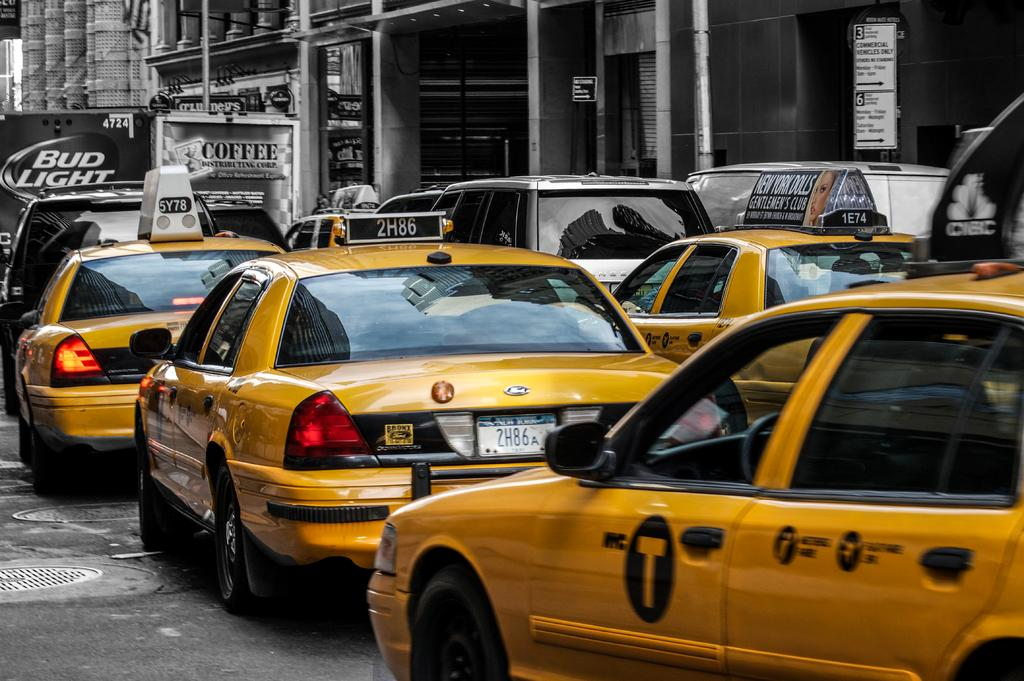<image>
Share a concise interpretation of the image provided. Several yellow taxi cabs are behind a Bud Light truck. 